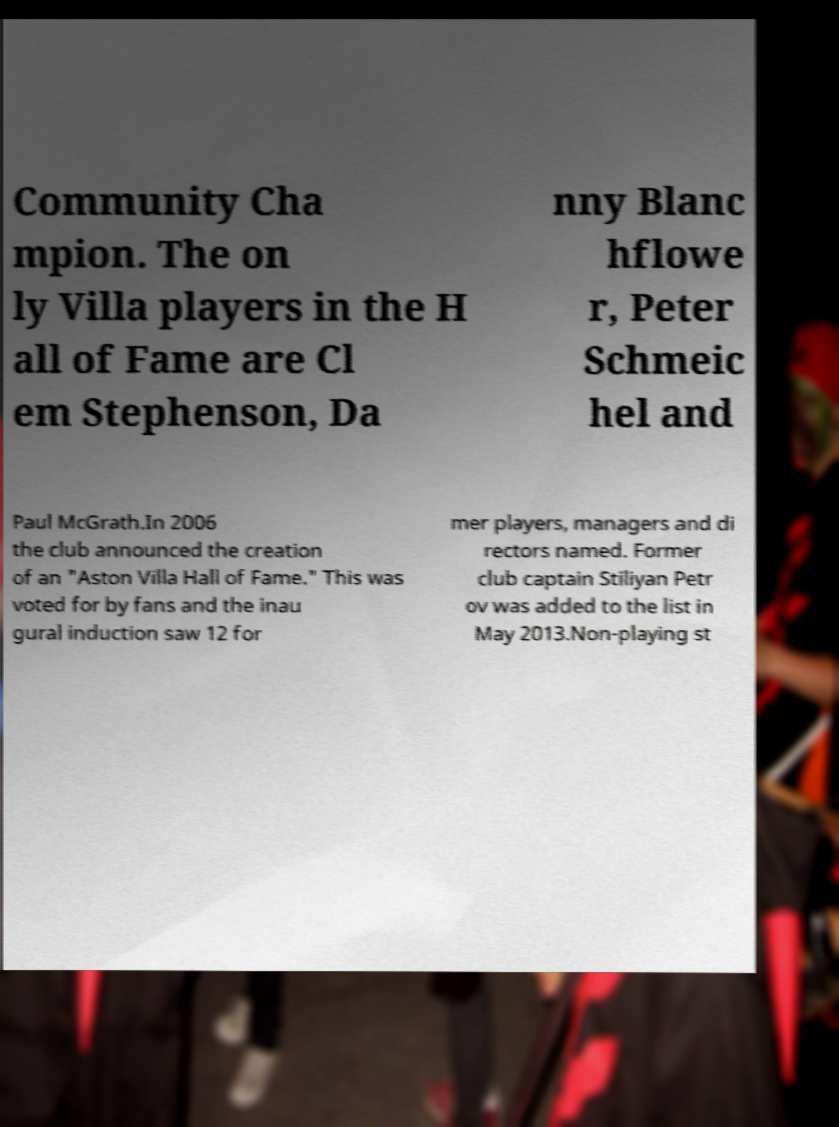Can you read and provide the text displayed in the image?This photo seems to have some interesting text. Can you extract and type it out for me? Community Cha mpion. The on ly Villa players in the H all of Fame are Cl em Stephenson, Da nny Blanc hflowe r, Peter Schmeic hel and Paul McGrath.In 2006 the club announced the creation of an "Aston Villa Hall of Fame." This was voted for by fans and the inau gural induction saw 12 for mer players, managers and di rectors named. Former club captain Stiliyan Petr ov was added to the list in May 2013.Non-playing st 